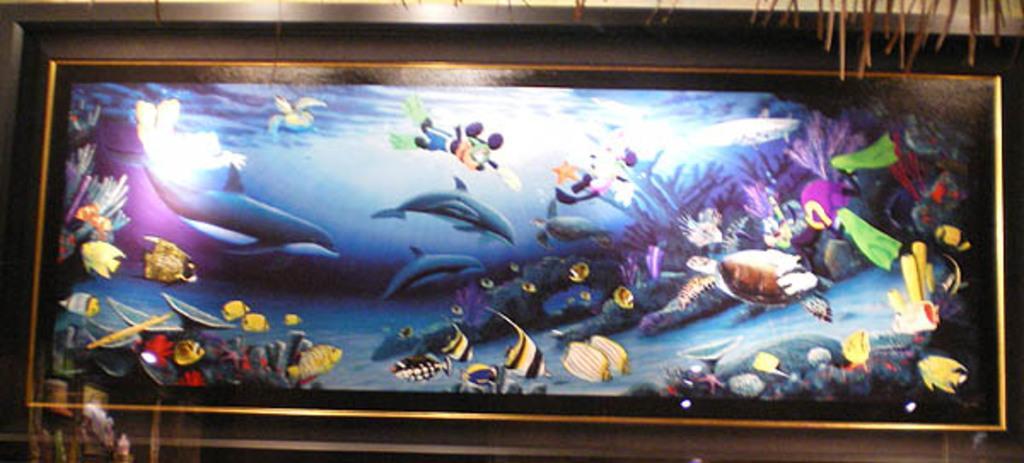Describe this image in one or two sentences. In This image there is one photo frame, in that photo frame there are some fishes and in the background there is a wall. 